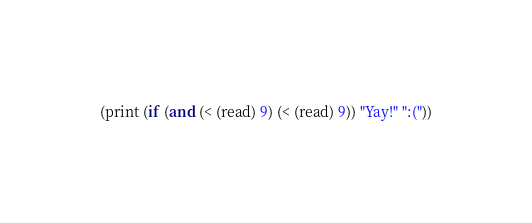Convert code to text. <code><loc_0><loc_0><loc_500><loc_500><_Scheme_>(print (if (and (< (read) 9) (< (read) 9)) "Yay!" ":("))</code> 